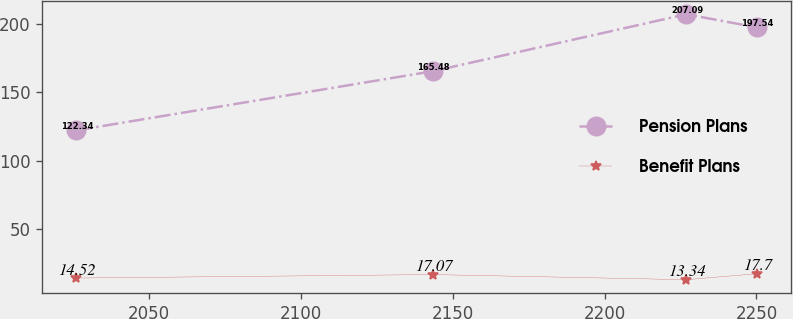Convert chart. <chart><loc_0><loc_0><loc_500><loc_500><line_chart><ecel><fcel>Pension Plans<fcel>Benefit Plans<nl><fcel>2026.11<fcel>122.34<fcel>14.52<nl><fcel>2143.41<fcel>165.48<fcel>17.07<nl><fcel>2226.91<fcel>207.09<fcel>13.34<nl><fcel>2250.11<fcel>197.54<fcel>17.7<nl></chart> 